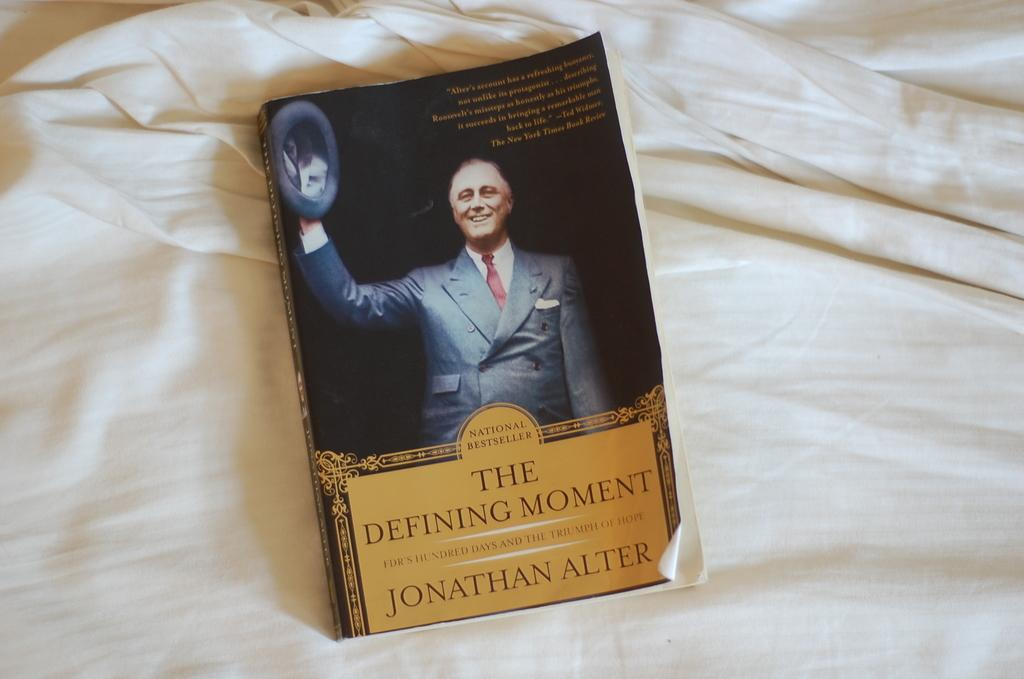<image>
Create a compact narrative representing the image presented. A paperback copy of The Defining Moment on a white sheet 